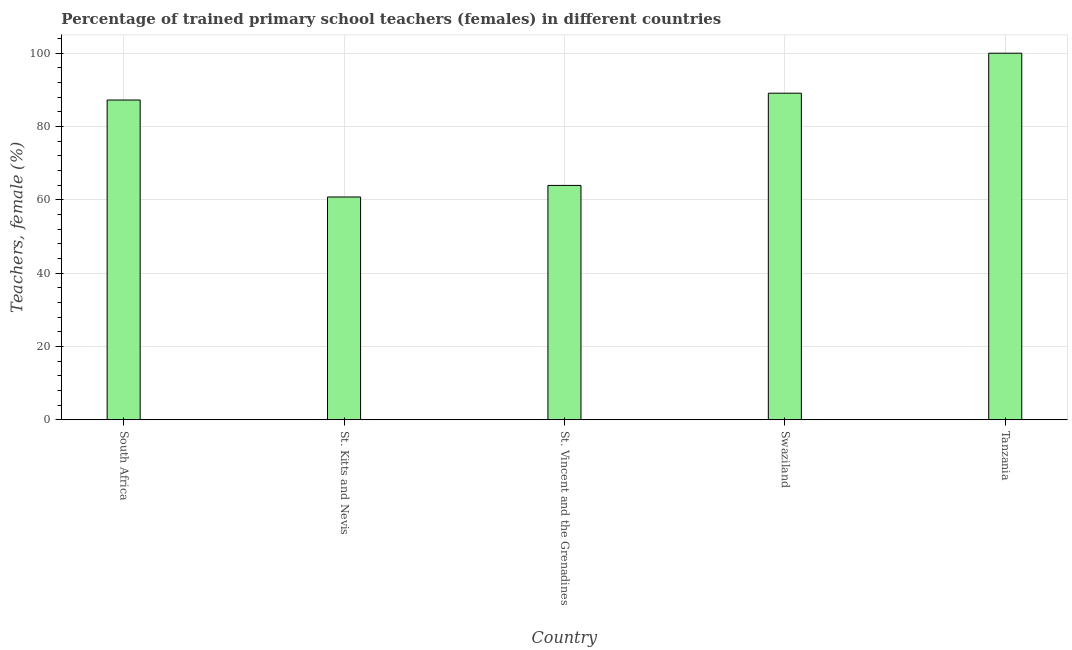What is the title of the graph?
Provide a short and direct response. Percentage of trained primary school teachers (females) in different countries. What is the label or title of the X-axis?
Your answer should be compact. Country. What is the label or title of the Y-axis?
Ensure brevity in your answer.  Teachers, female (%). Across all countries, what is the minimum percentage of trained female teachers?
Your answer should be compact. 60.78. In which country was the percentage of trained female teachers maximum?
Keep it short and to the point. Tanzania. In which country was the percentage of trained female teachers minimum?
Provide a succinct answer. St. Kitts and Nevis. What is the sum of the percentage of trained female teachers?
Your response must be concise. 401.04. What is the difference between the percentage of trained female teachers in St. Vincent and the Grenadines and Tanzania?
Give a very brief answer. -36.07. What is the average percentage of trained female teachers per country?
Your response must be concise. 80.21. What is the median percentage of trained female teachers?
Provide a succinct answer. 87.23. What is the ratio of the percentage of trained female teachers in South Africa to that in St. Kitts and Nevis?
Your answer should be very brief. 1.44. Is the difference between the percentage of trained female teachers in South Africa and St. Vincent and the Grenadines greater than the difference between any two countries?
Keep it short and to the point. No. What is the difference between the highest and the second highest percentage of trained female teachers?
Your response must be concise. 10.91. Is the sum of the percentage of trained female teachers in St. Vincent and the Grenadines and Tanzania greater than the maximum percentage of trained female teachers across all countries?
Provide a succinct answer. Yes. What is the difference between the highest and the lowest percentage of trained female teachers?
Provide a succinct answer. 39.22. In how many countries, is the percentage of trained female teachers greater than the average percentage of trained female teachers taken over all countries?
Keep it short and to the point. 3. How many countries are there in the graph?
Offer a very short reply. 5. Are the values on the major ticks of Y-axis written in scientific E-notation?
Your response must be concise. No. What is the Teachers, female (%) in South Africa?
Your answer should be compact. 87.23. What is the Teachers, female (%) in St. Kitts and Nevis?
Your response must be concise. 60.78. What is the Teachers, female (%) of St. Vincent and the Grenadines?
Ensure brevity in your answer.  63.93. What is the Teachers, female (%) of Swaziland?
Your response must be concise. 89.09. What is the Teachers, female (%) in Tanzania?
Offer a terse response. 100. What is the difference between the Teachers, female (%) in South Africa and St. Kitts and Nevis?
Provide a succinct answer. 26.44. What is the difference between the Teachers, female (%) in South Africa and St. Vincent and the Grenadines?
Your answer should be very brief. 23.29. What is the difference between the Teachers, female (%) in South Africa and Swaziland?
Offer a terse response. -1.86. What is the difference between the Teachers, female (%) in South Africa and Tanzania?
Make the answer very short. -12.77. What is the difference between the Teachers, female (%) in St. Kitts and Nevis and St. Vincent and the Grenadines?
Offer a very short reply. -3.15. What is the difference between the Teachers, female (%) in St. Kitts and Nevis and Swaziland?
Ensure brevity in your answer.  -28.31. What is the difference between the Teachers, female (%) in St. Kitts and Nevis and Tanzania?
Make the answer very short. -39.22. What is the difference between the Teachers, female (%) in St. Vincent and the Grenadines and Swaziland?
Give a very brief answer. -25.16. What is the difference between the Teachers, female (%) in St. Vincent and the Grenadines and Tanzania?
Offer a terse response. -36.07. What is the difference between the Teachers, female (%) in Swaziland and Tanzania?
Provide a succinct answer. -10.91. What is the ratio of the Teachers, female (%) in South Africa to that in St. Kitts and Nevis?
Give a very brief answer. 1.44. What is the ratio of the Teachers, female (%) in South Africa to that in St. Vincent and the Grenadines?
Give a very brief answer. 1.36. What is the ratio of the Teachers, female (%) in South Africa to that in Swaziland?
Ensure brevity in your answer.  0.98. What is the ratio of the Teachers, female (%) in South Africa to that in Tanzania?
Offer a very short reply. 0.87. What is the ratio of the Teachers, female (%) in St. Kitts and Nevis to that in St. Vincent and the Grenadines?
Give a very brief answer. 0.95. What is the ratio of the Teachers, female (%) in St. Kitts and Nevis to that in Swaziland?
Offer a terse response. 0.68. What is the ratio of the Teachers, female (%) in St. Kitts and Nevis to that in Tanzania?
Your answer should be very brief. 0.61. What is the ratio of the Teachers, female (%) in St. Vincent and the Grenadines to that in Swaziland?
Your response must be concise. 0.72. What is the ratio of the Teachers, female (%) in St. Vincent and the Grenadines to that in Tanzania?
Keep it short and to the point. 0.64. What is the ratio of the Teachers, female (%) in Swaziland to that in Tanzania?
Provide a short and direct response. 0.89. 